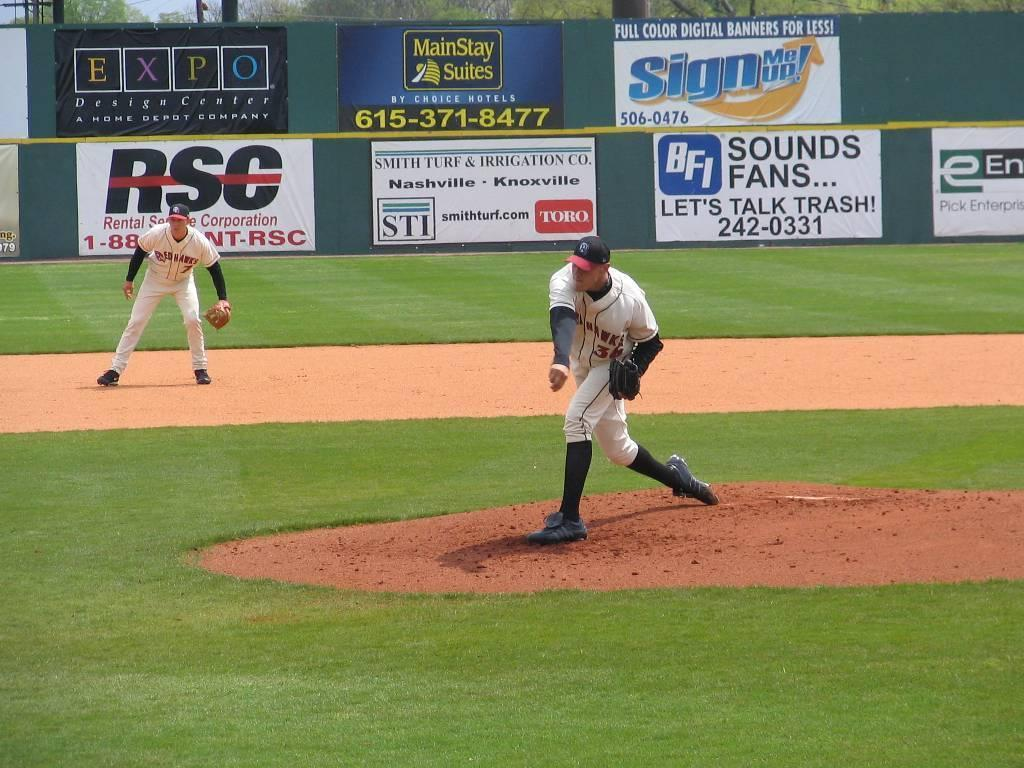<image>
Offer a succinct explanation of the picture presented. The pitcher for the Redhawks has just thrown a pitch. 